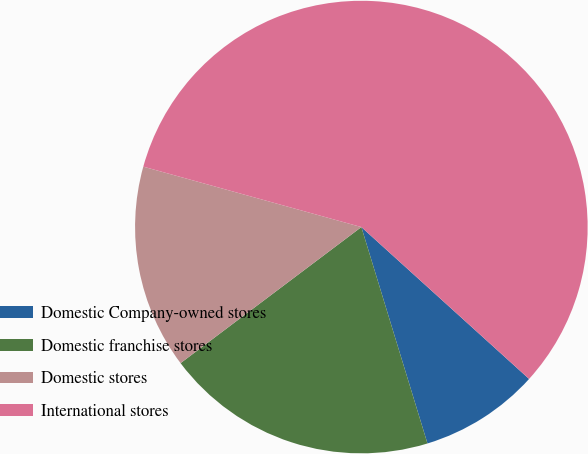<chart> <loc_0><loc_0><loc_500><loc_500><pie_chart><fcel>Domestic Company-owned stores<fcel>Domestic franchise stores<fcel>Domestic stores<fcel>International stores<nl><fcel>8.57%<fcel>19.45%<fcel>14.57%<fcel>57.41%<nl></chart> 